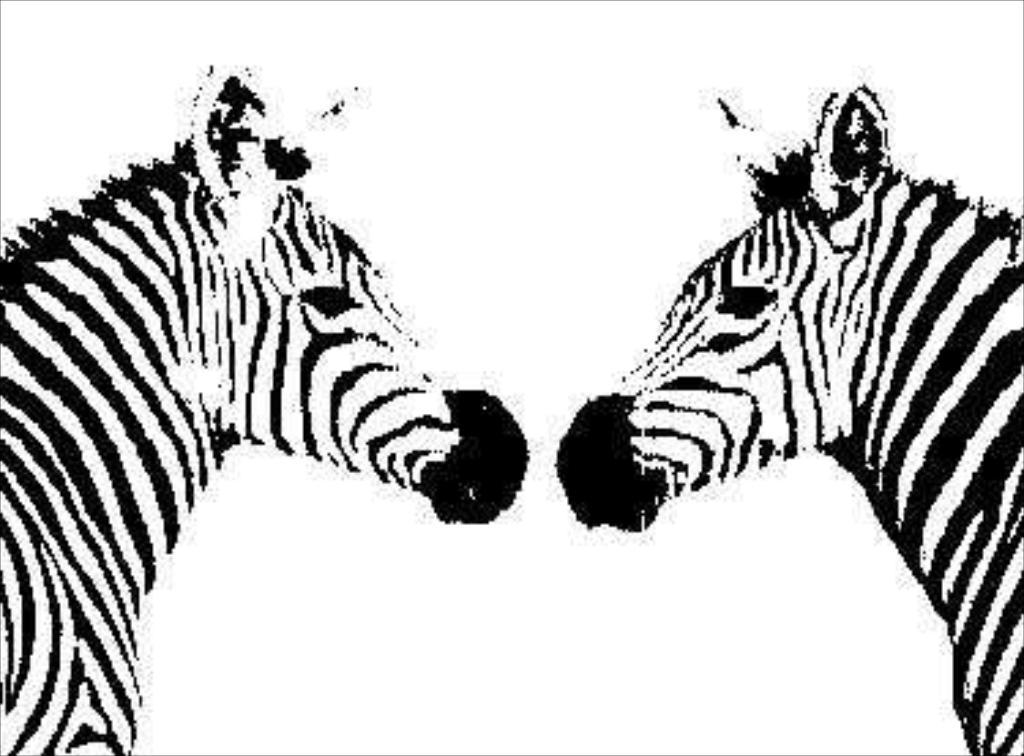What animals are present in the image? There are zebras in the image. What color is the background of the image? The background of the image is white. What type of yam is being cooked in the image? There is no yam present in the image; it features zebras with a white background. Can you hear the thunder in the image? There is no sound in the image, so it is not possible to hear thunder or any other sounds. 